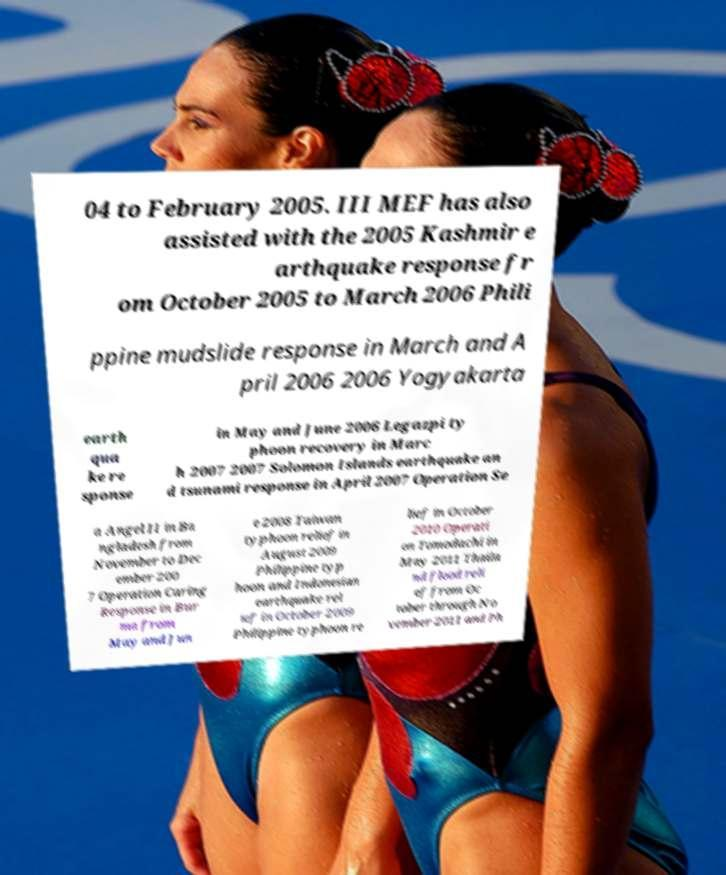For documentation purposes, I need the text within this image transcribed. Could you provide that? 04 to February 2005. III MEF has also assisted with the 2005 Kashmir e arthquake response fr om October 2005 to March 2006 Phili ppine mudslide response in March and A pril 2006 2006 Yogyakarta earth qua ke re sponse in May and June 2006 Legazpi ty phoon recovery in Marc h 2007 2007 Solomon Islands earthquake an d tsunami response in April 2007 Operation Se a Angel II in Ba ngladesh from November to Dec ember 200 7 Operation Caring Response in Bur ma from May and Jun e 2008 Taiwan typhoon relief in August 2009 Philippine typ hoon and Indonesian earthquake rel ief in October 2009 Philippine typhoon re lief in October 2010 Operati on Tomodachi in May 2011 Thaila nd flood reli ef from Oc tober through No vember 2011 and Ph 